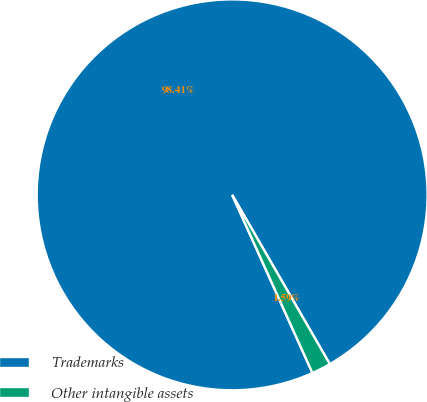Convert chart to OTSL. <chart><loc_0><loc_0><loc_500><loc_500><pie_chart><fcel>Trademarks<fcel>Other intangible assets<nl><fcel>98.41%<fcel>1.59%<nl></chart> 